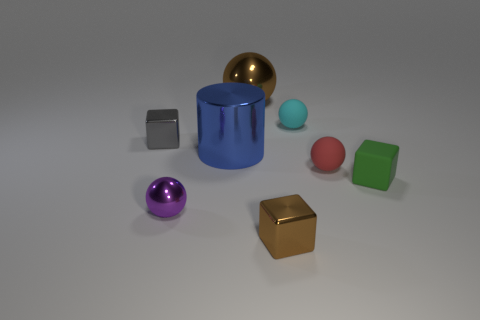Are there any brown objects of the same shape as the gray metal thing?
Keep it short and to the point. Yes. Are there more cubes that are right of the cyan thing than brown metal cylinders?
Keep it short and to the point. Yes. What number of metallic objects are either purple objects or large things?
Ensure brevity in your answer.  3. There is a shiny thing that is both in front of the green block and left of the big blue cylinder; how big is it?
Your response must be concise. Small. There is a small metallic block to the left of the blue object; are there any large metallic balls to the right of it?
Offer a terse response. Yes. There is a small gray thing; how many objects are right of it?
Provide a succinct answer. 7. The other big object that is the same shape as the purple object is what color?
Keep it short and to the point. Brown. Is the block on the left side of the big blue cylinder made of the same material as the sphere that is to the right of the small cyan matte object?
Your answer should be very brief. No. Is the color of the large metal sphere the same as the shiny cube in front of the red matte thing?
Provide a succinct answer. Yes. There is a shiny object that is both behind the purple ball and on the right side of the big blue object; what is its shape?
Your response must be concise. Sphere. 